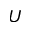<formula> <loc_0><loc_0><loc_500><loc_500>U</formula> 